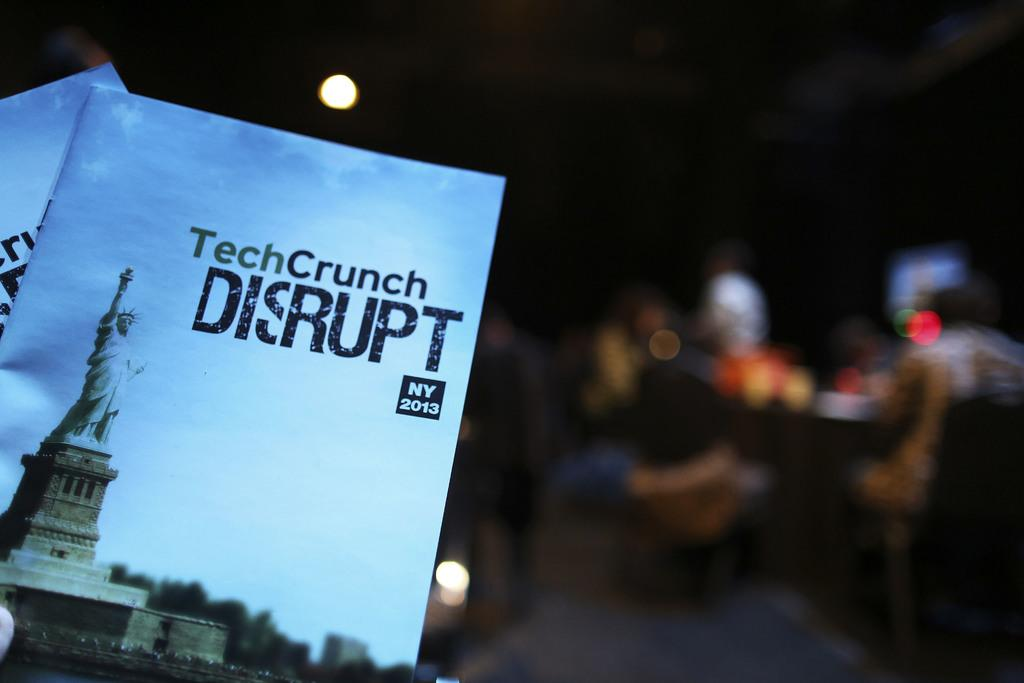What objects are on the left side of the image? There are books on the left side of the image. What can be seen on the books? The books have text on them. Can you describe the background of the image? The background of the image is blurred. How many houses are visible in the image? There are no houses visible in the image; it only features books with text on them and a blurred background. What type of pump is present in the image? There is no pump present in the image. 